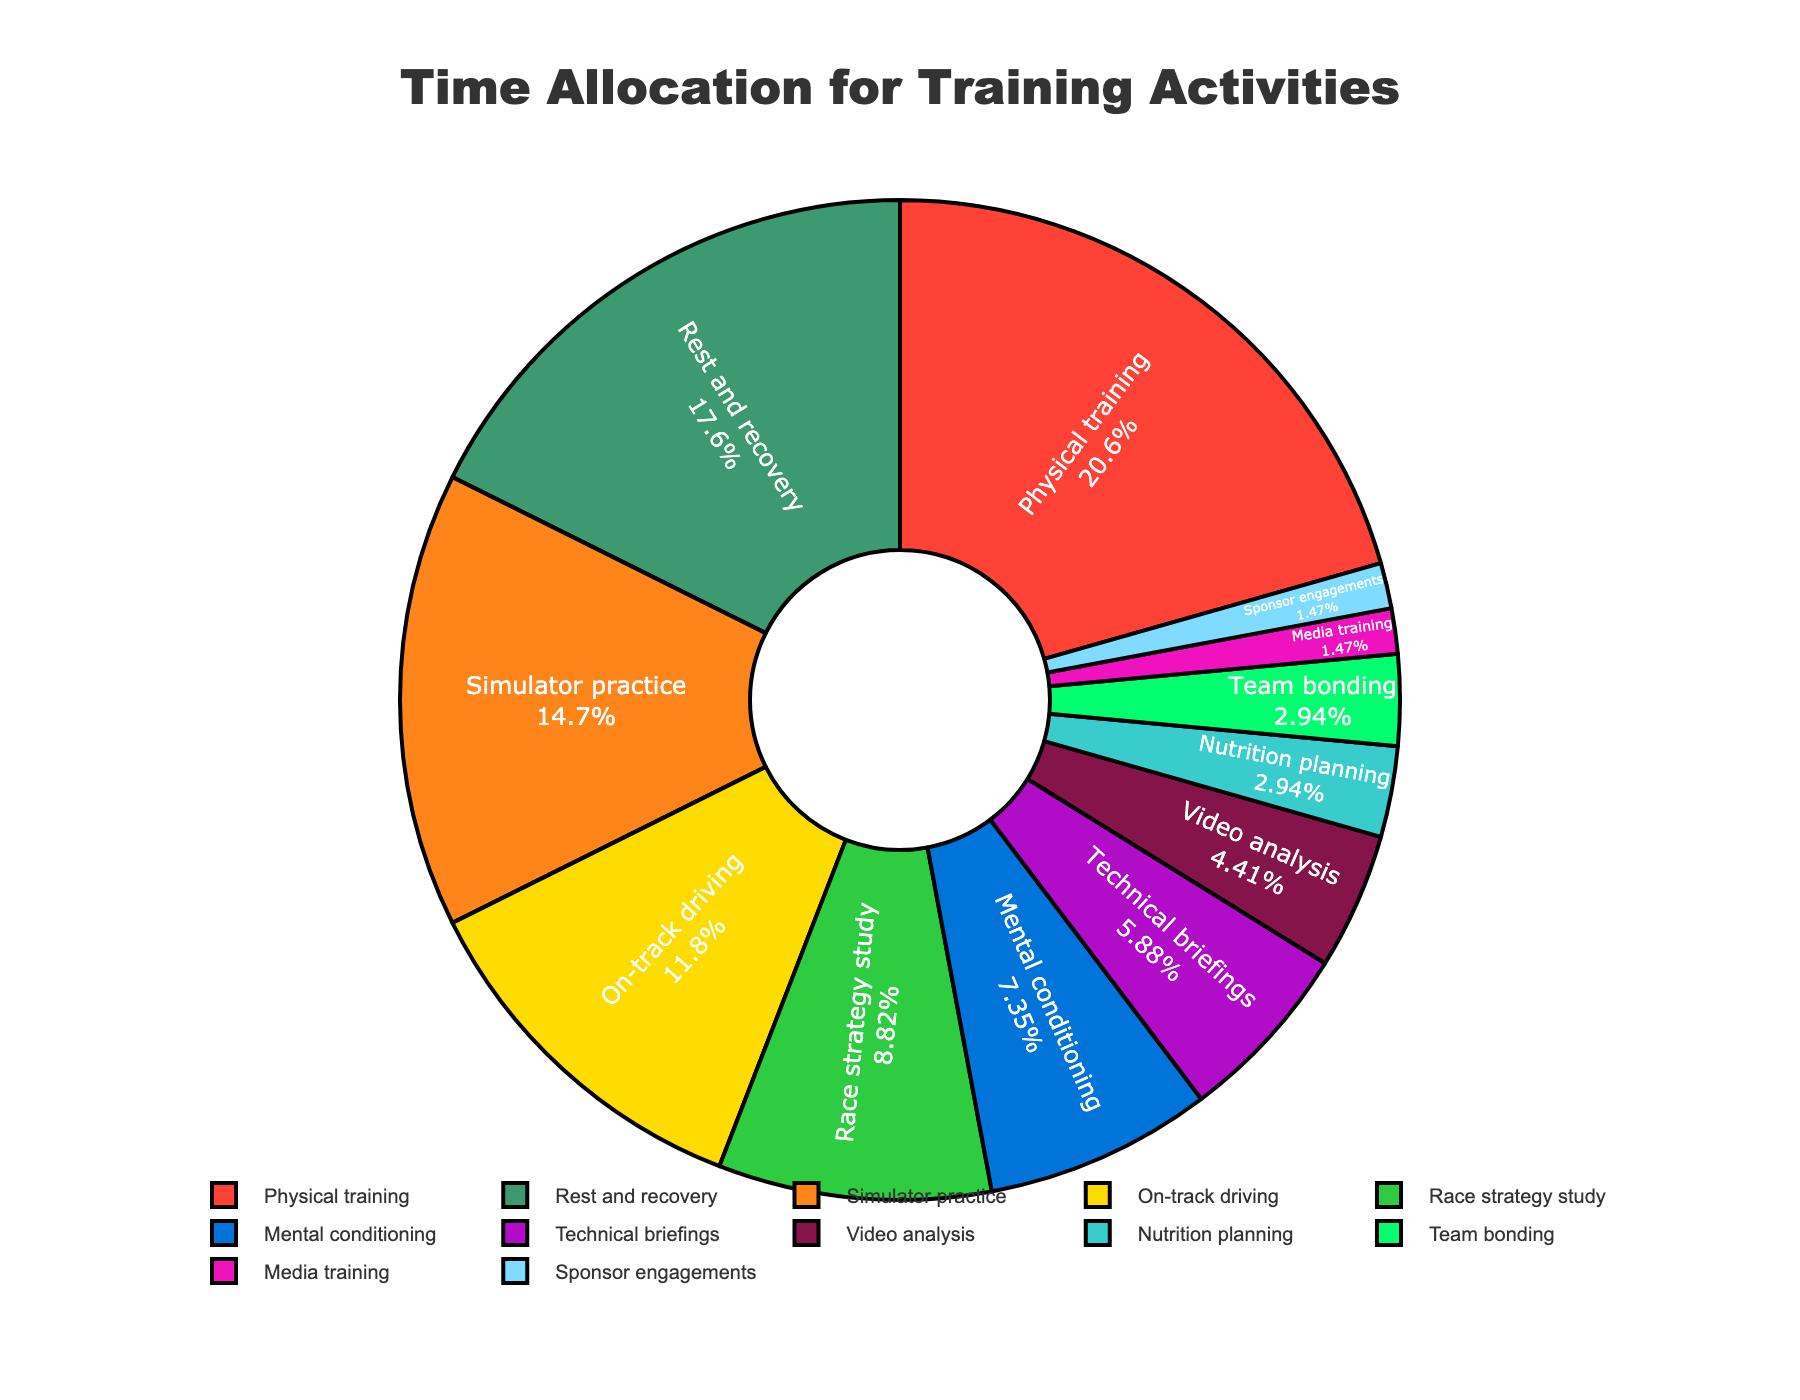What's the largest segment in the pie chart? The largest segment is the one that occupies the biggest area in the pie chart. In this case, it's described as “Rest and recovery.”
Answer: Rest and recovery Which activity takes up the smallest amount of time? The smallest segment is the one that occupies the least area in the pie chart. In this case, it’s “Media training” and “Sponsor engagements.”
Answer: Media training and Sponsor engagements How much more time is spent on physical training compared to mental conditioning? Physical training occupies 14 hours and mental conditioning takes up 5 hours. The difference is found by subtracting 5 from 14.
Answer: 9 hours What activities together constitute exactly half of the total time allocation? To find what constitutes half of the total time allocation (which is 64 hours/2 = 32 hours), add up activities. "Rest and recovery" (12 hours), "Physical training" (14 hours), and "Simulator practice" (10 hours) sum up to 36 hours, exceeding half by 4 hours. Adding "On-track driving" (8 hours) and "Race strategy study" (6 hours) results in a combination to get closest half without exceeding: "Rest and recovery" (12), "Physical training" (14), "Mental conditioning" (5), and "Technical briefings" (4) sum is 35 hours. "Rest and recovery," "Simulator practice," & "Mental conditioning" sum to 27 hours, adding "Technical briefings" is 31, close. Combine further to exactly 32 might involve split subdivisions.
Answer: Combinative 32 hours Which activity takes up more time, video analysis or nutrition planning? Compare the hours for video analysis (3) and nutrition planning (2). Video analysis has one more hour than nutrition planning.
Answer: Video analysis What percentage of the total time is spent on on-track driving? On-track driving takes 8 hours. To find the percentage, divide 8 by the total hours (64) and multiply by 100. 8 / 64 * 100 = 12.5%.
Answer: 12.5% Are more hours spent on physical training or simulator practice? Physical training takes 14 hours, while simulator practice takes 10 hours. Since 14 is greater than 10, more hours are spent on physical training.
Answer: Physical training How does the time spent on technical briefings compare to the time spent on mental conditioning? Technical briefings take 4 hours, and mental conditioning takes 5 hours. Since 5 is greater than 4, more time is spent on mental conditioning.
Answer: Mental conditioning What's the total amount of time spent on activities involving either physical or mental conditioning? Physical training takes 14 hours and mental conditioning takes 5 hours. Adding these gives 14 + 5 = 19 hours.
Answer: 19 hours 